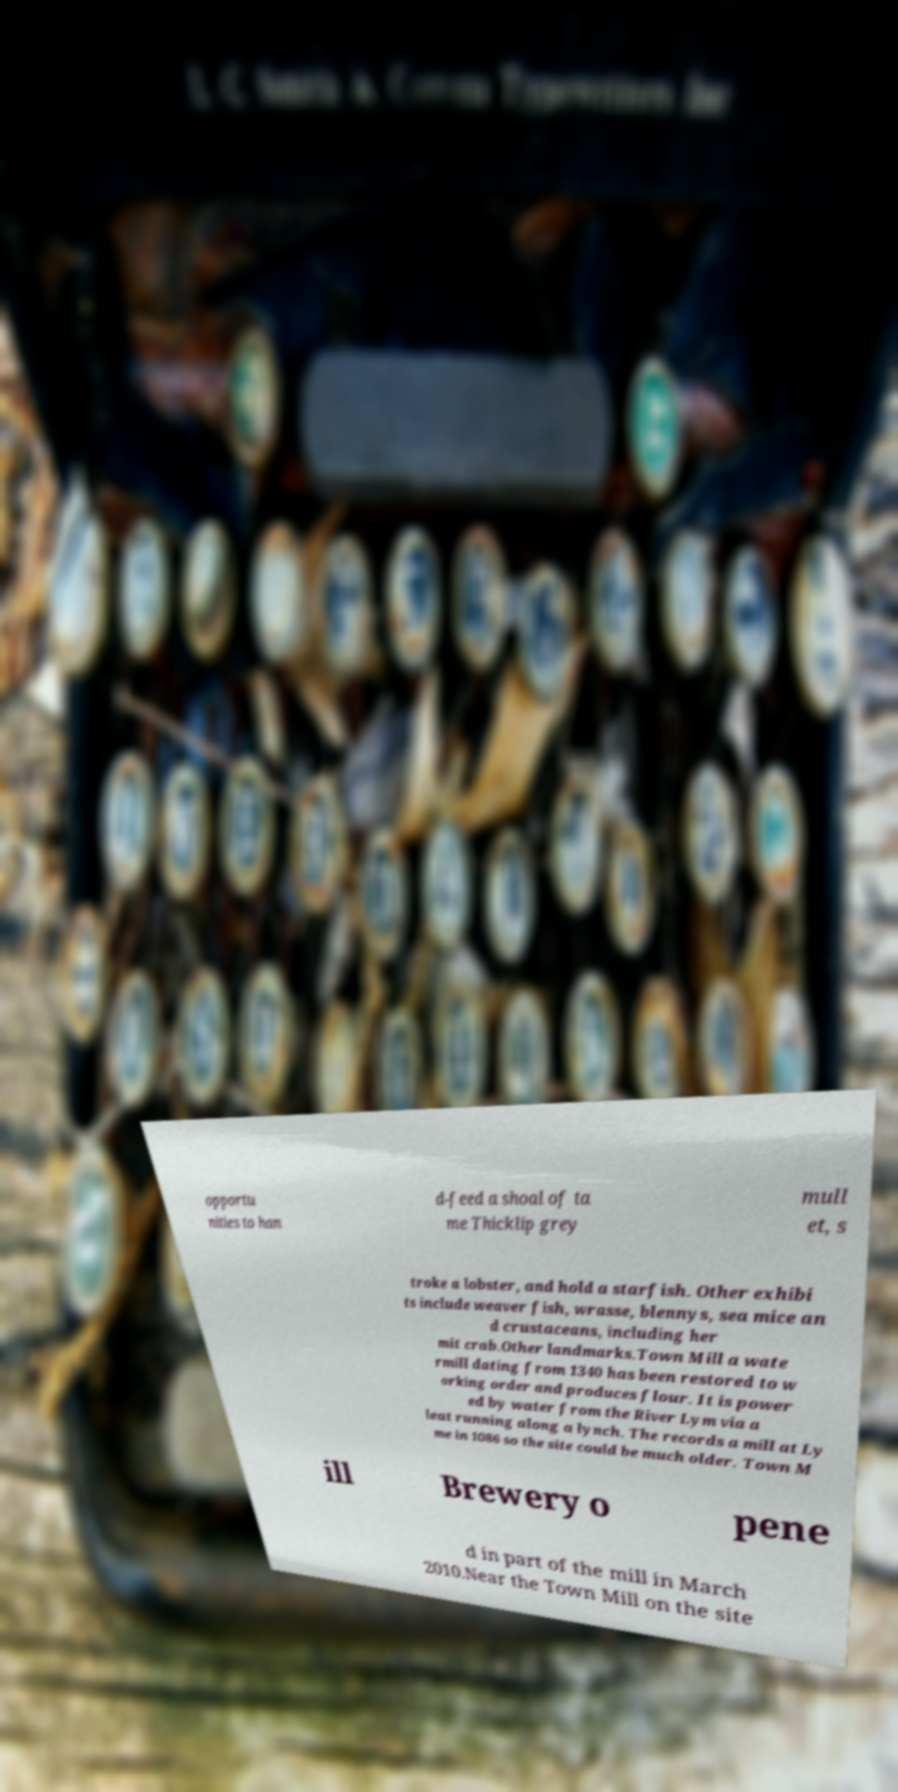Could you assist in decoding the text presented in this image and type it out clearly? opportu nities to han d-feed a shoal of ta me Thicklip grey mull et, s troke a lobster, and hold a starfish. Other exhibi ts include weaver fish, wrasse, blennys, sea mice an d crustaceans, including her mit crab.Other landmarks.Town Mill a wate rmill dating from 1340 has been restored to w orking order and produces flour. It is power ed by water from the River Lym via a leat running along a lynch. The records a mill at Ly me in 1086 so the site could be much older. Town M ill Brewery o pene d in part of the mill in March 2010.Near the Town Mill on the site 